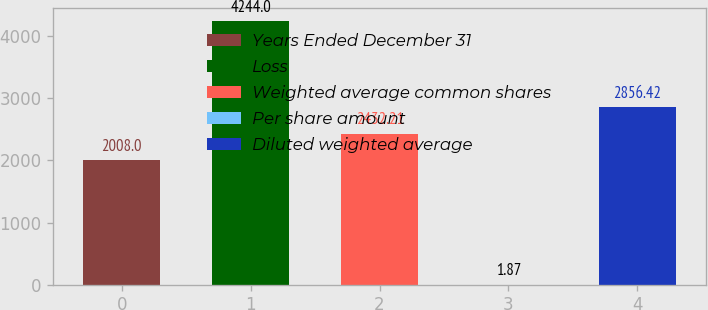Convert chart to OTSL. <chart><loc_0><loc_0><loc_500><loc_500><bar_chart><fcel>Years Ended December 31<fcel>Loss<fcel>Weighted average common shares<fcel>Per share amount<fcel>Diluted weighted average<nl><fcel>2008<fcel>4244<fcel>2432.21<fcel>1.87<fcel>2856.42<nl></chart> 